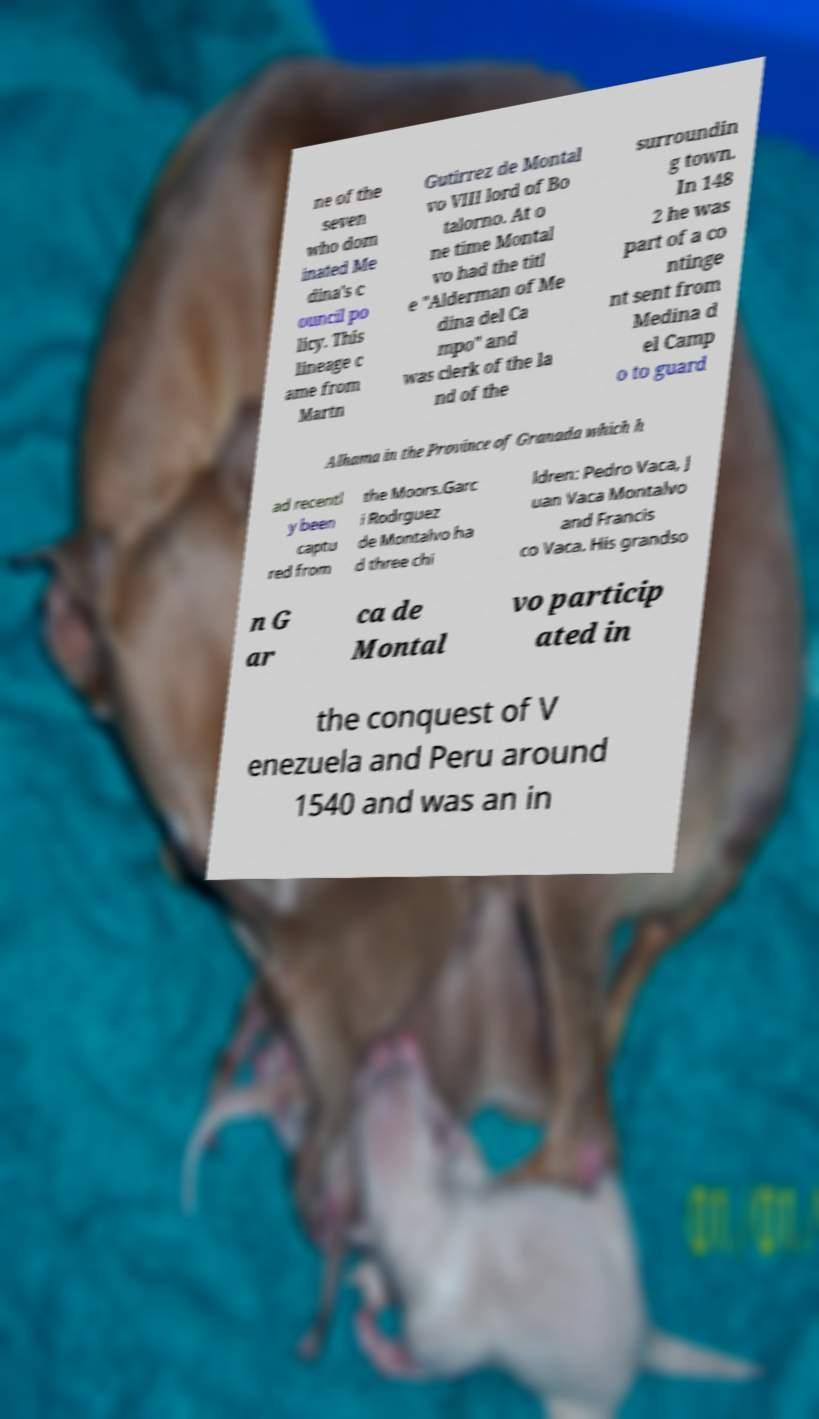What messages or text are displayed in this image? I need them in a readable, typed format. ne of the seven who dom inated Me dina's c ouncil po licy. This lineage c ame from Martn Gutirrez de Montal vo VIII lord of Bo talorno. At o ne time Montal vo had the titl e "Alderman of Me dina del Ca mpo" and was clerk of the la nd of the surroundin g town. In 148 2 he was part of a co ntinge nt sent from Medina d el Camp o to guard Alhama in the Province of Granada which h ad recentl y been captu red from the Moors.Garc i Rodrguez de Montalvo ha d three chi ldren: Pedro Vaca, J uan Vaca Montalvo and Francis co Vaca. His grandso n G ar ca de Montal vo particip ated in the conquest of V enezuela and Peru around 1540 and was an in 